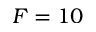Convert formula to latex. <formula><loc_0><loc_0><loc_500><loc_500>F = 1 0</formula> 